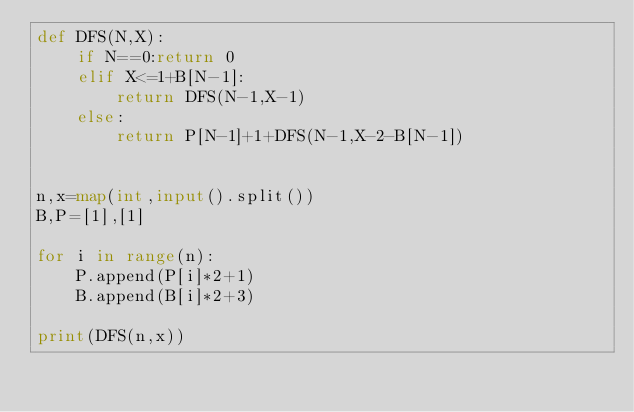<code> <loc_0><loc_0><loc_500><loc_500><_Python_>def DFS(N,X):
    if N==0:return 0
    elif X<=1+B[N-1]:
        return DFS(N-1,X-1)
    else:
        return P[N-1]+1+DFS(N-1,X-2-B[N-1])


n,x=map(int,input().split())
B,P=[1],[1]

for i in range(n):
    P.append(P[i]*2+1)
    B.append(B[i]*2+3)

print(DFS(n,x))
</code> 